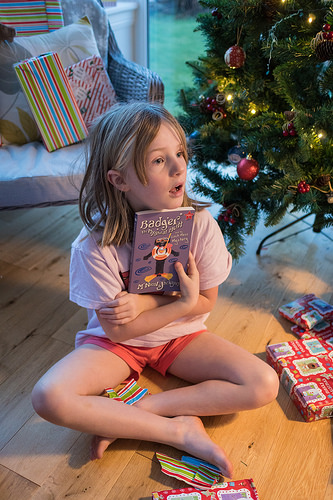<image>
Is there a present above the girl? No. The present is not positioned above the girl. The vertical arrangement shows a different relationship. 